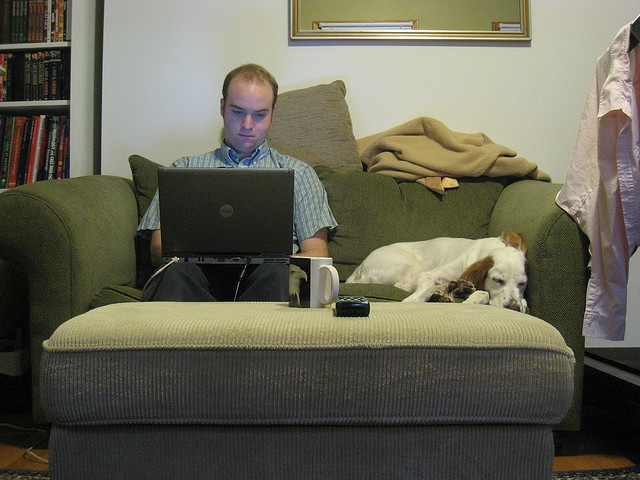Describe the objects in this image and their specific colors. I can see couch in black, darkgreen, gray, and tan tones, people in black, gray, and darkgray tones, laptop in black, gray, and darkgreen tones, dog in black, beige, and tan tones, and book in black, maroon, gray, and darkgreen tones in this image. 